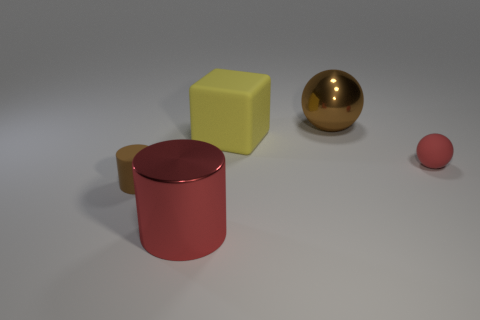Subtract 1 cylinders. How many cylinders are left? 1 Add 5 yellow matte cubes. How many objects exist? 10 Subtract all blocks. How many objects are left? 4 Subtract 0 blue cylinders. How many objects are left? 5 Subtract all yellow spheres. Subtract all brown cubes. How many spheres are left? 2 Subtract all gray balls. How many gray cylinders are left? 0 Subtract all green spheres. Subtract all balls. How many objects are left? 3 Add 4 small brown cylinders. How many small brown cylinders are left? 5 Add 4 big balls. How many big balls exist? 5 